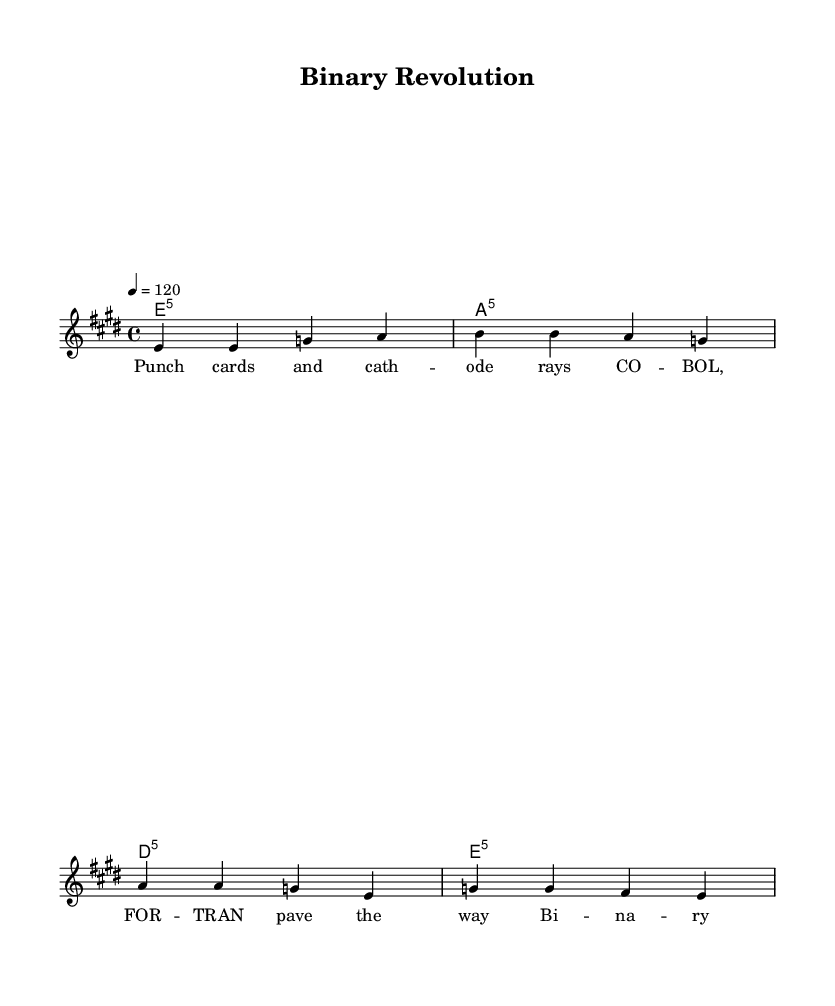What is the key signature of this music? The key signature is E major, which has four sharps (F#, C#, G#, D#). We can tell because the key signature is indicated at the beginning of the staff and matches the notes played throughout the piece.
Answer: E major What is the time signature of this music? The time signature is 4/4, which specifies that there are four beats in each measure and a quarter note receives one beat. This is shown at the beginning of the piece next to the key signature.
Answer: 4/4 What is the tempo marking for this music? The tempo marking is quarter note equals 120, indicating the speed of the piece. It tells us the tempo is 120 beats per minute, which can be found just above the staff.
Answer: 120 How many measures are there in the score? There are four measures in total, each separated by vertical bar lines. We can count the bar lines to see that there are four distinct sections of music.
Answer: 4 What type of chords are used in the harmony? The harmony consists of power chords, or fifth chords, indicated by the formula 'e1:5', 'a1:5', 'd1:5', and 'e1:5'. This shows that the root and fifth notes are played together, a common feature in rock music.
Answer: Power chords What is the primary theme of the lyrics in this piece? The primary theme of the lyrics revolves around early computing concepts, as shown in phrases like "Punch cards" and "Bi-na-ry re-vo-lu-tion". This suggests the song discusses the history of programming and technology.
Answer: Early computing What lyrical style is used in this music? The lyrics are in a rhythmic and syllabic style that matches the melody, shown by the placement of the words under the corresponding notes. The lyrics follow a structured verse form commonly found in rock anthems.
Answer: Structured verse 